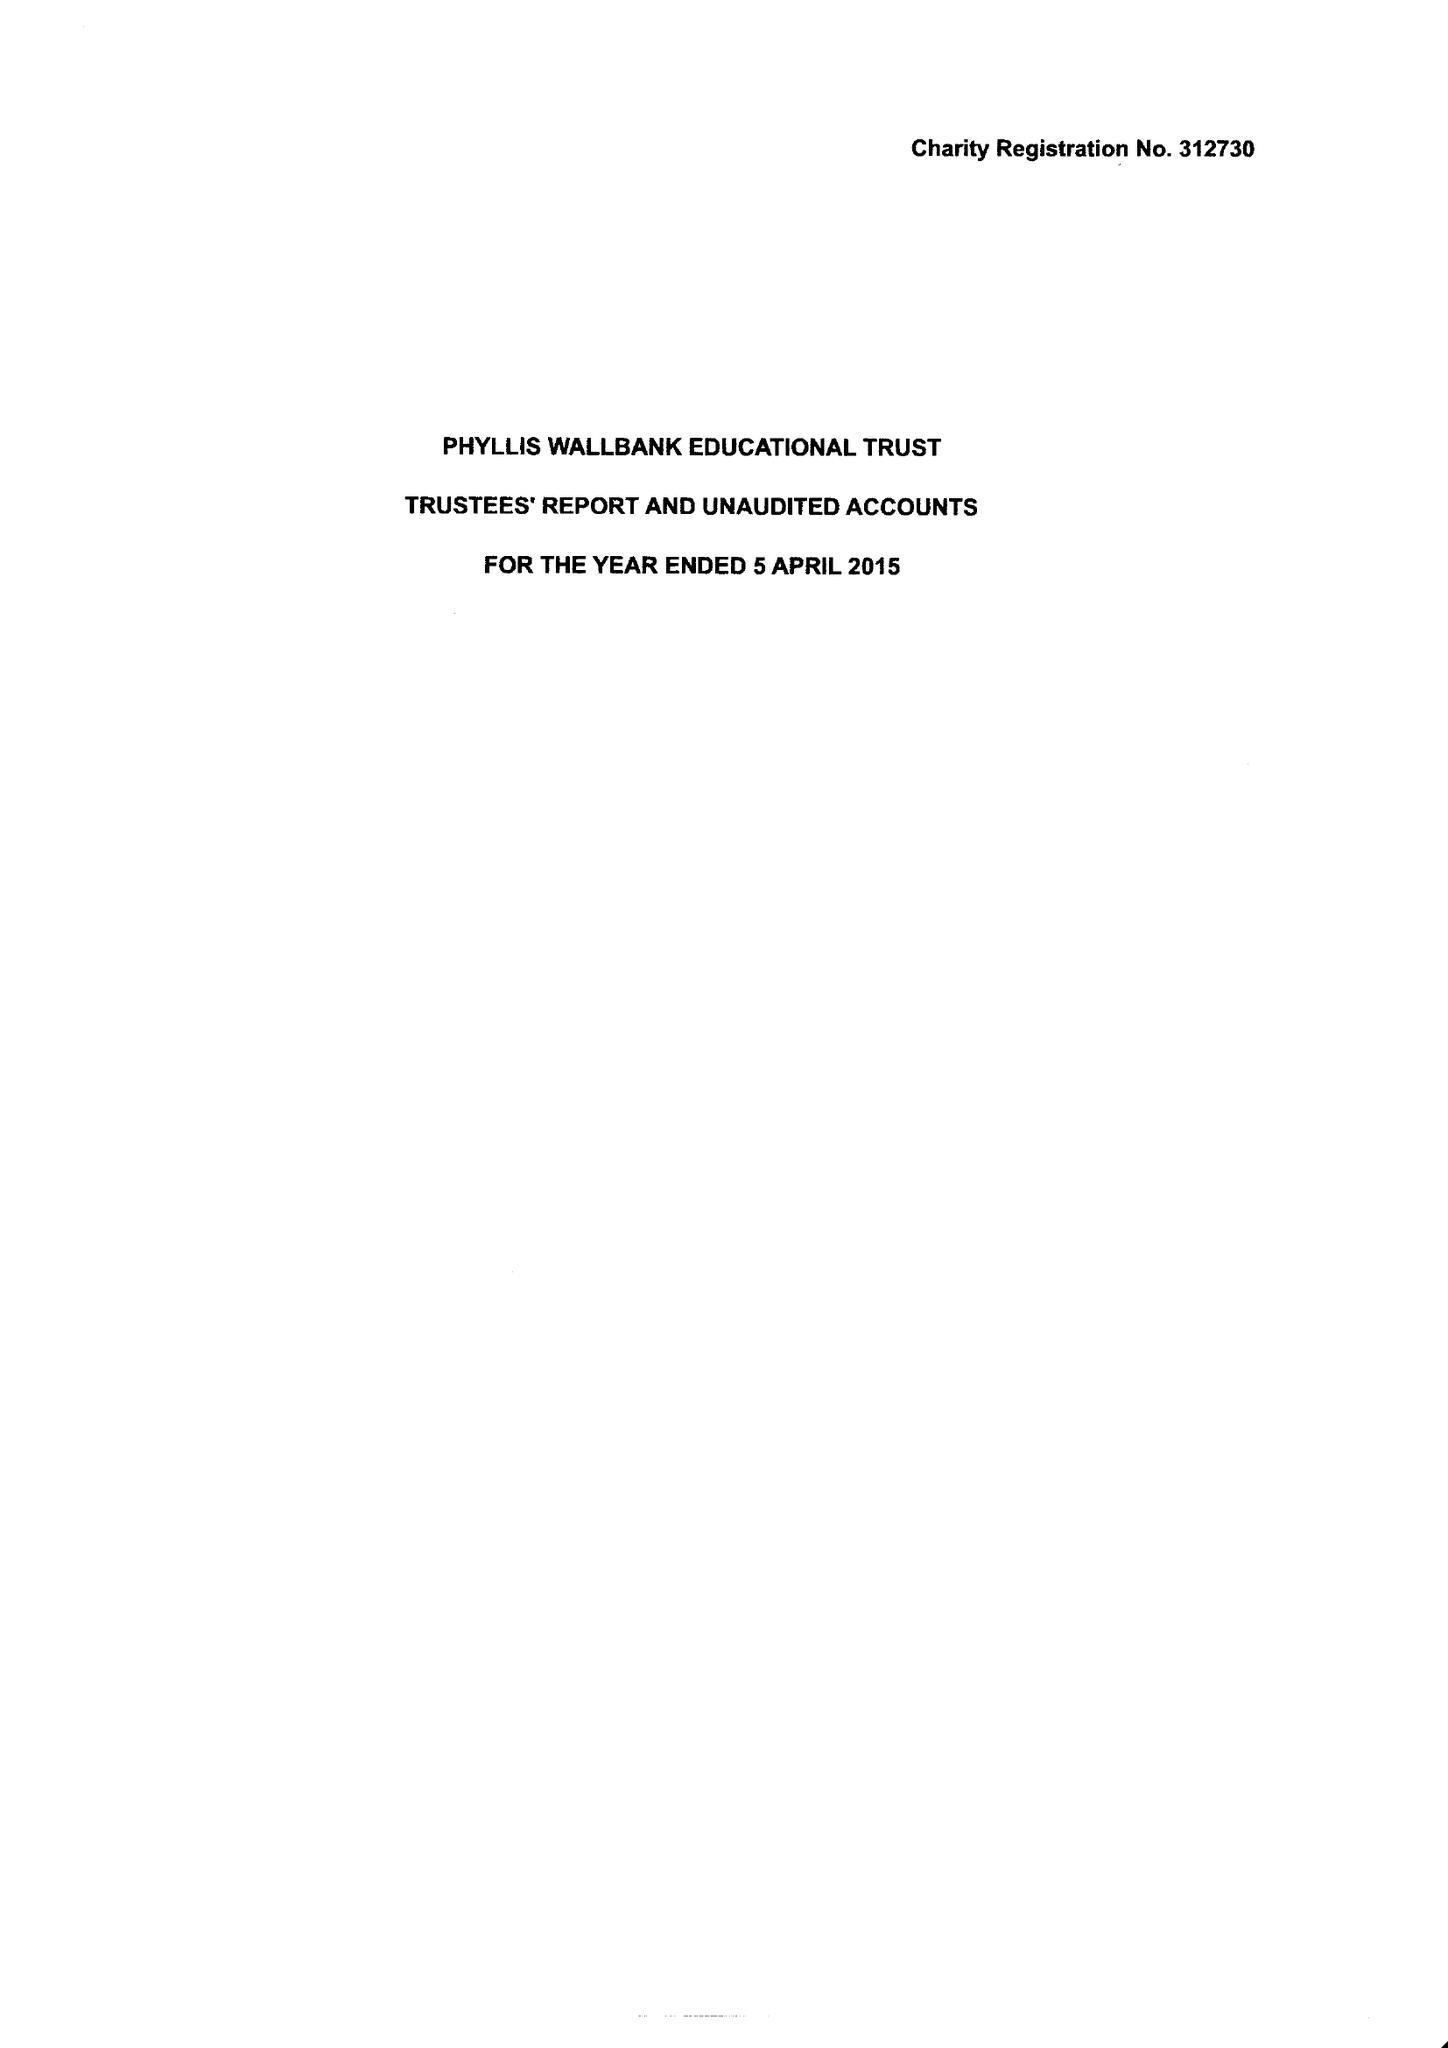What is the value for the address__postcode?
Answer the question using a single word or phrase. NW1 9TY 